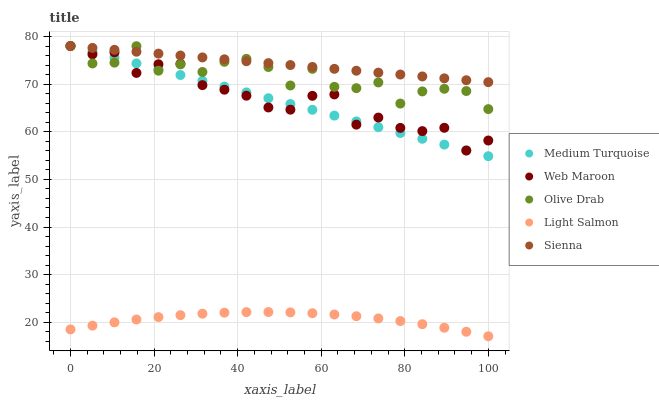Does Light Salmon have the minimum area under the curve?
Answer yes or no. Yes. Does Sienna have the maximum area under the curve?
Answer yes or no. Yes. Does Web Maroon have the minimum area under the curve?
Answer yes or no. No. Does Web Maroon have the maximum area under the curve?
Answer yes or no. No. Is Sienna the smoothest?
Answer yes or no. Yes. Is Olive Drab the roughest?
Answer yes or no. Yes. Is Light Salmon the smoothest?
Answer yes or no. No. Is Light Salmon the roughest?
Answer yes or no. No. Does Light Salmon have the lowest value?
Answer yes or no. Yes. Does Web Maroon have the lowest value?
Answer yes or no. No. Does Medium Turquoise have the highest value?
Answer yes or no. Yes. Does Light Salmon have the highest value?
Answer yes or no. No. Is Light Salmon less than Web Maroon?
Answer yes or no. Yes. Is Web Maroon greater than Light Salmon?
Answer yes or no. Yes. Does Olive Drab intersect Medium Turquoise?
Answer yes or no. Yes. Is Olive Drab less than Medium Turquoise?
Answer yes or no. No. Is Olive Drab greater than Medium Turquoise?
Answer yes or no. No. Does Light Salmon intersect Web Maroon?
Answer yes or no. No. 